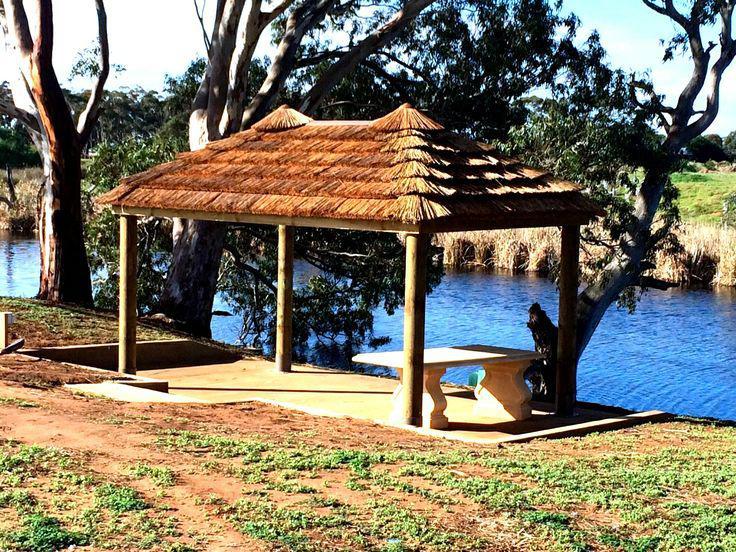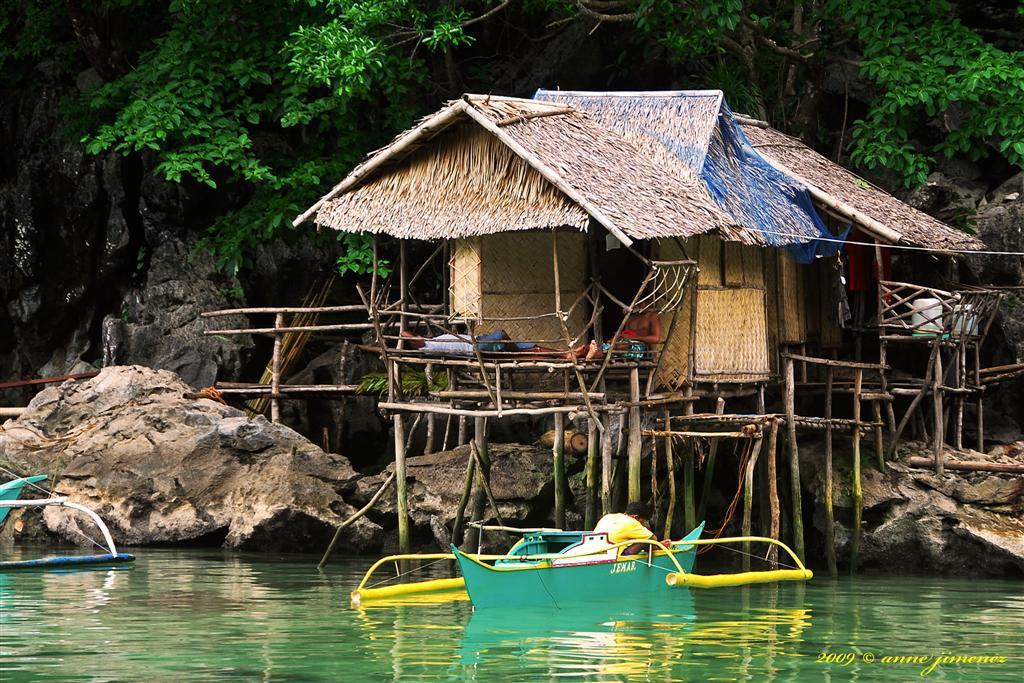The first image is the image on the left, the second image is the image on the right. For the images displayed, is the sentence "In the left image a table is covered by a roof." factually correct? Answer yes or no. Yes. The first image is the image on the left, the second image is the image on the right. Evaluate the accuracy of this statement regarding the images: "One image shows a thatched umbrella shape over a seating area with a round table.". Is it true? Answer yes or no. No. 